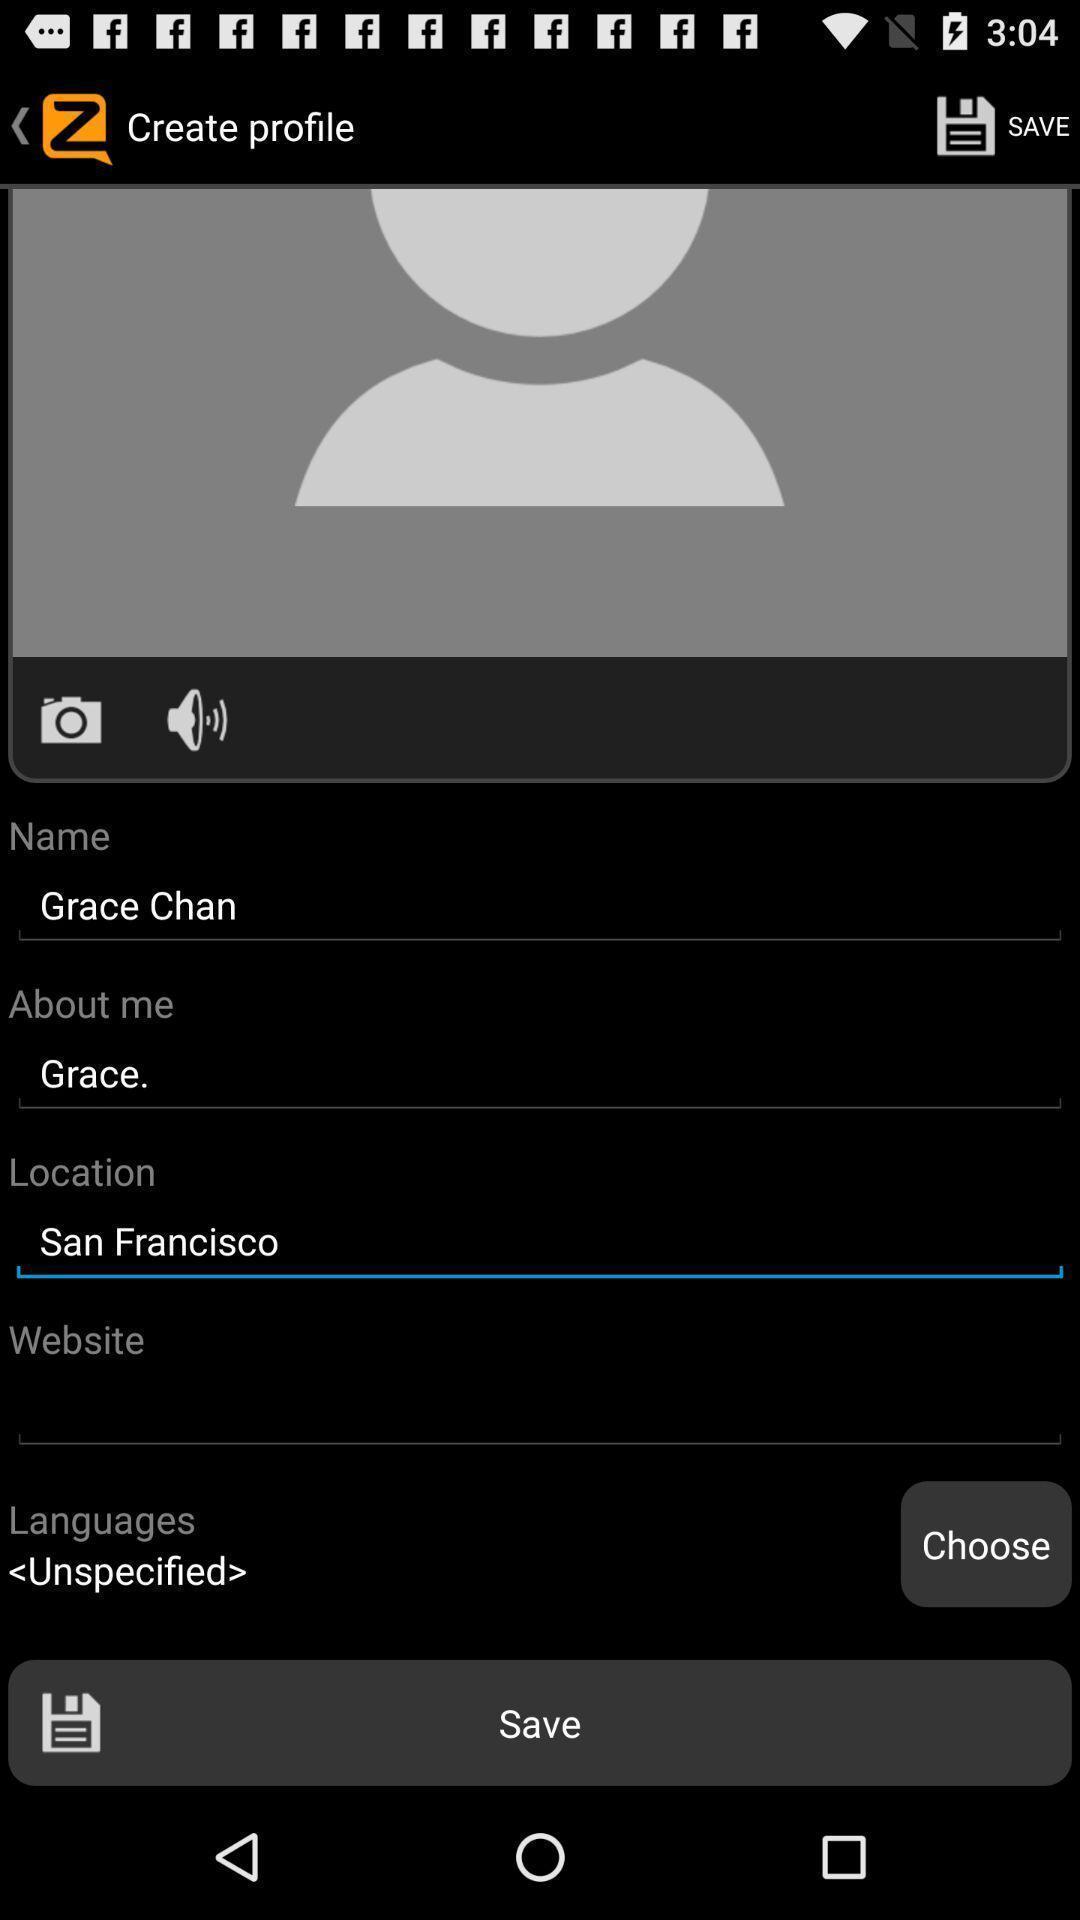What can you discern from this picture? Screen displaying the options in create profile. 